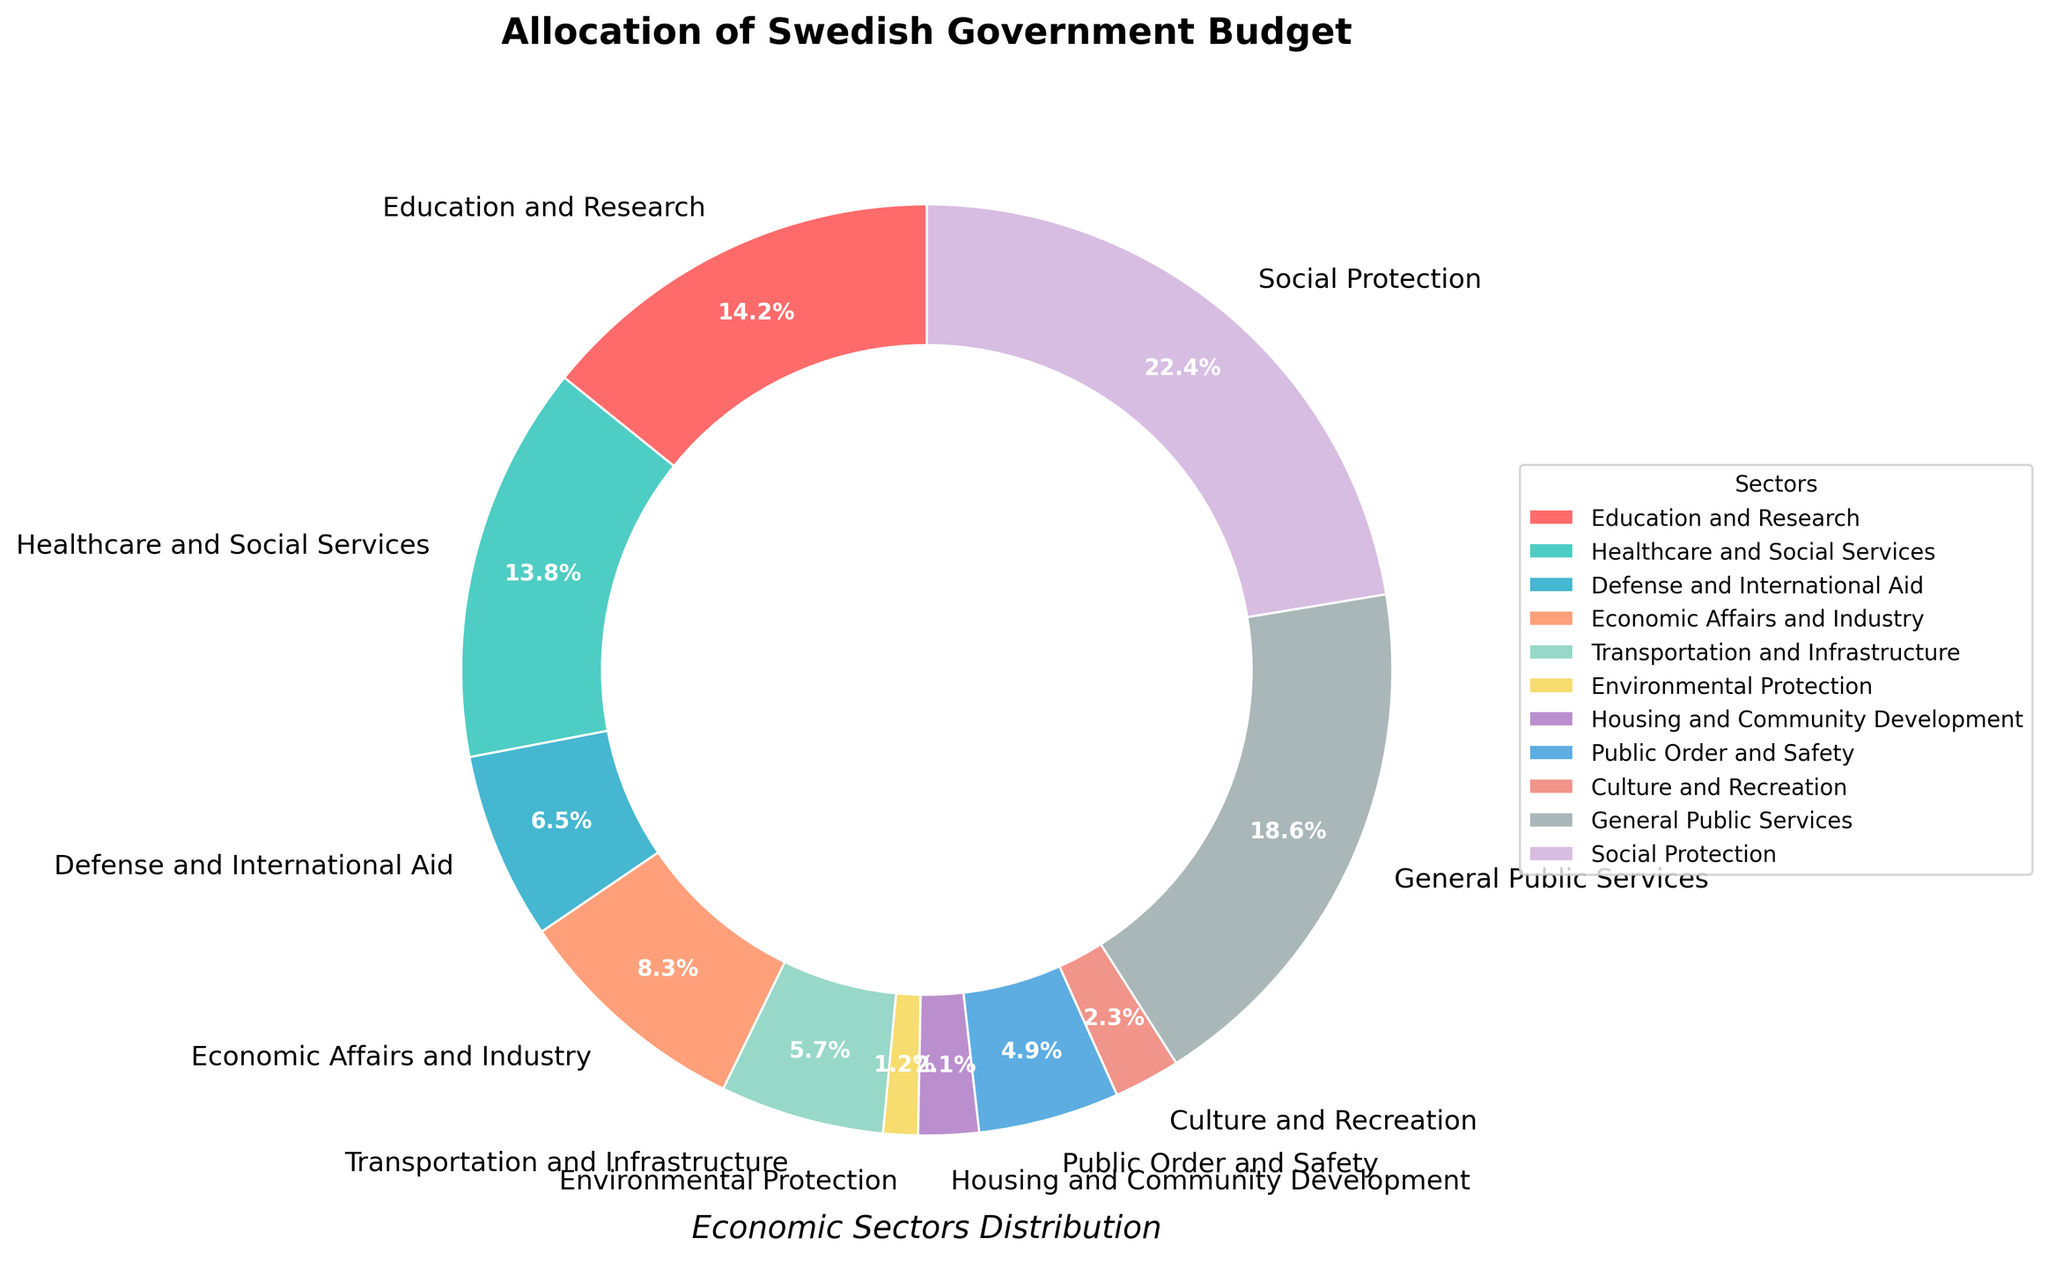Which sector has the highest budget allocation? By examining the pie chart, observe the size of each slice and find the one with the largest area. The label on this slice indicates the sector with the highest budget allocation.
Answer: Social Protection What is the combined budget allocation for Education and Research and Healthcare and Social Services? Identify the percentages for both sectors from the pie chart, then add them together: Education and Research (14.2%) and Healthcare and Social Services (13.8%), summing to 14.2% + 13.8% = 28%.
Answer: 28% What is the difference in budget allocation between General Public Services and Economic Affairs and Industry? Locate the percentages for both sectors in the pie chart: General Public Services (18.6%) and Economic Affairs and Industry (8.3%). Subtract the smaller percentage from the larger percentage: 18.6% - 8.3% = 10.3%.
Answer: 10.3% Which sector has a smaller budget allocation: Housing and Community Development or Culture and Recreation? Look at the percentages for both sectors: Housing and Community Development (2.1%) and Culture and Recreation (2.3%). Compare the two percentages and identify the smaller one.
Answer: Housing and Community Development What is the total budget percentage for the sectors with allocations under 5%? Identify all sectors with percentages below 5%: Environmental Protection (1.2%), Housing and Community Development (2.1%), Public Order and Safety (4.9%), Culture and Recreation (2.3%). Sum these percentages: 1.2% + 2.1% + 4.9% + 2.3% = 10.5%.
Answer: 10.5% Which sector is represented by the red slice in the pie chart? From the provided colors and order, the red slice corresponds to the first sector listed. In this case, it is Education and Research.
Answer: Education and Research 